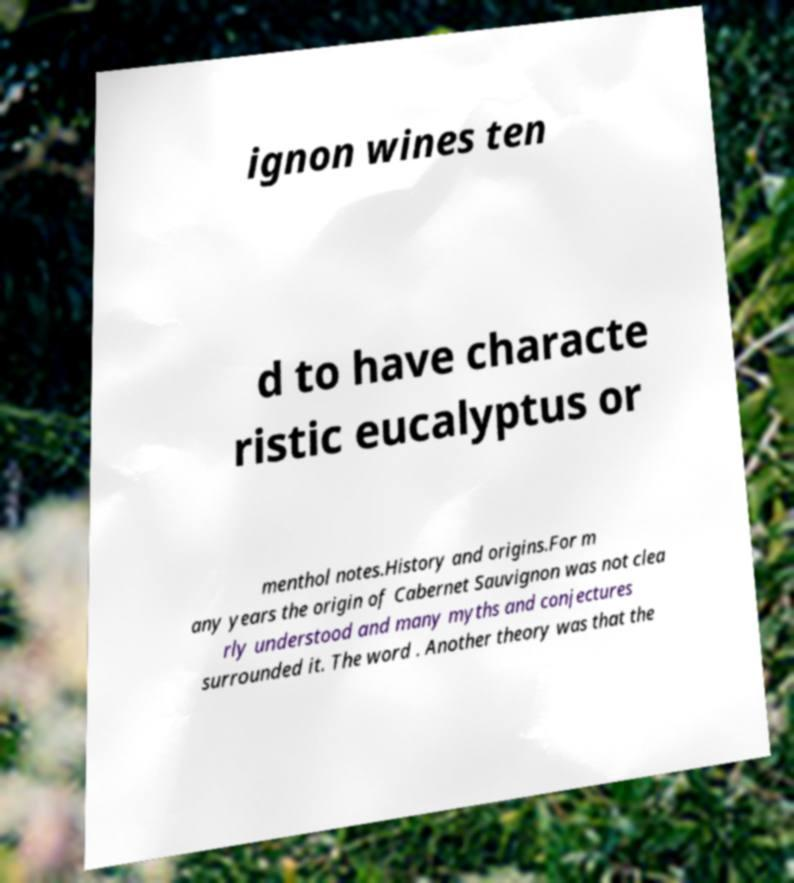There's text embedded in this image that I need extracted. Can you transcribe it verbatim? ignon wines ten d to have characte ristic eucalyptus or menthol notes.History and origins.For m any years the origin of Cabernet Sauvignon was not clea rly understood and many myths and conjectures surrounded it. The word . Another theory was that the 